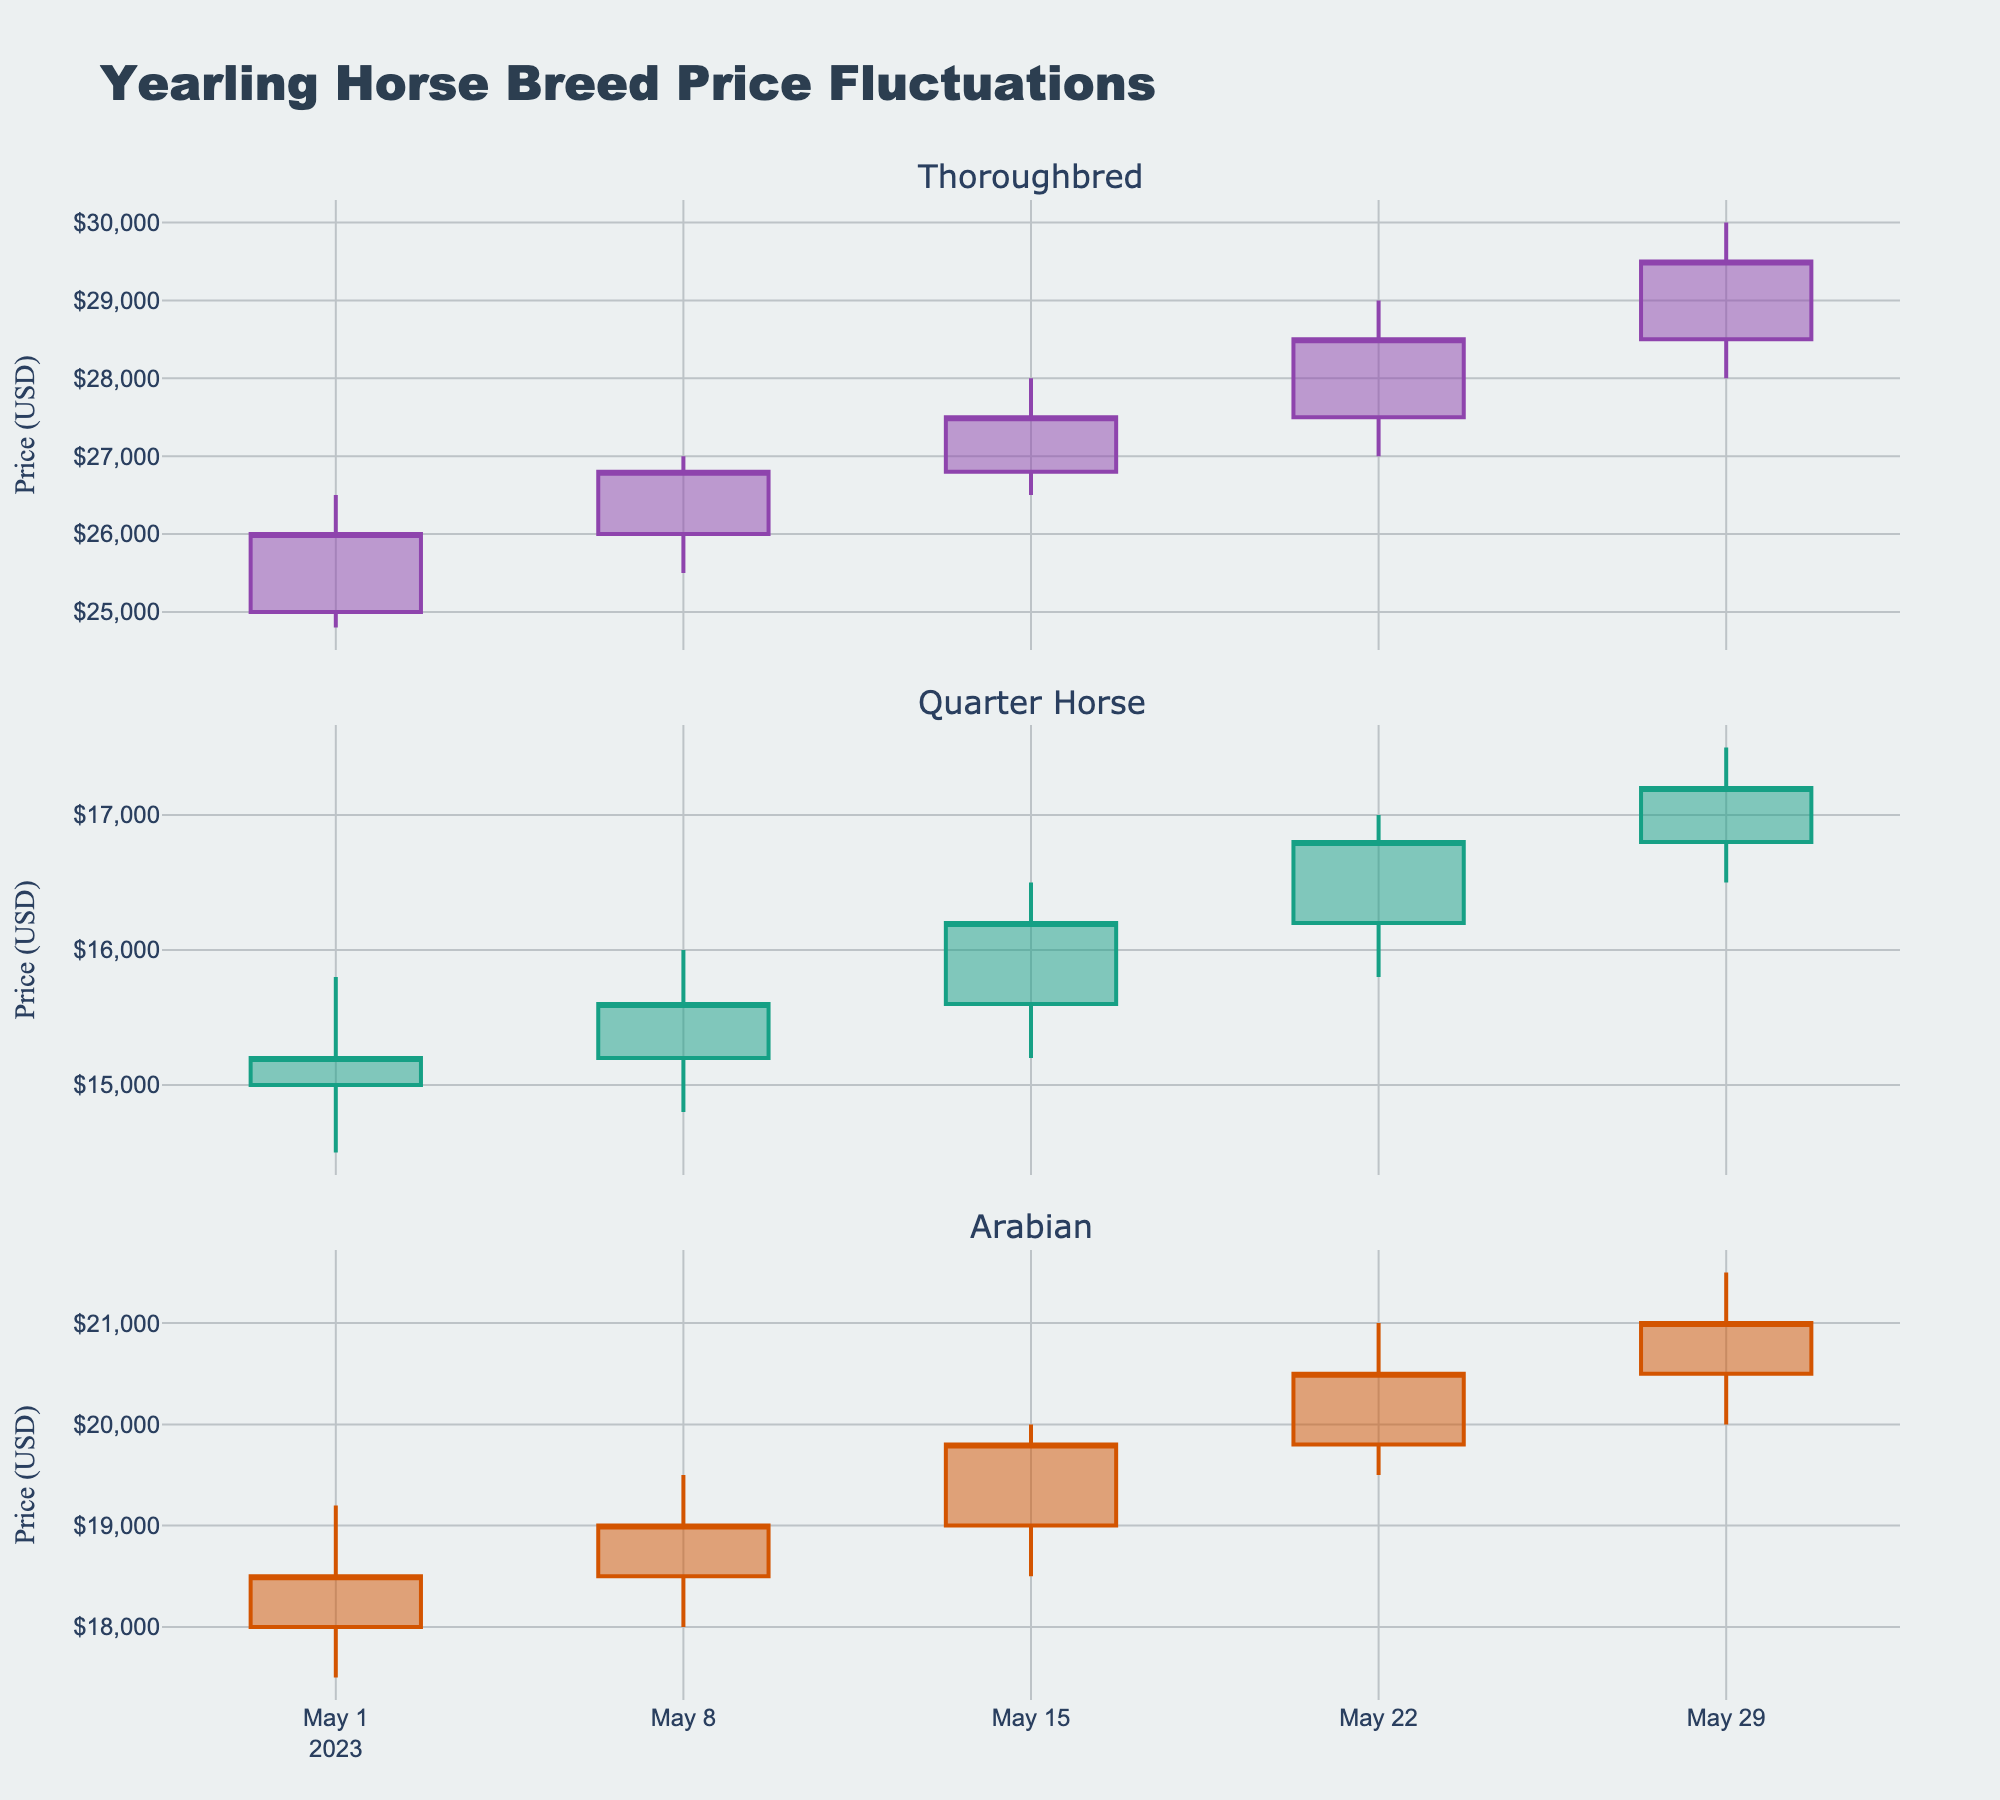Which month is the data from? The title of the chart indicates that it reflects monthly data, and the x-axis shows dates. Since the dates range from 2023-05-01 to 2023-05-29, the month is May 2023.
Answer: May 2023 How many different yearling horse breeds are shown in the chart? The title of the chart mentions "Yearling Horse Breed Price Fluctuations," and there are three subplots labeled Thoroughbred, Quarter Horse, and Arabian.
Answer: Three What is the closing price of the Thoroughbred on May 15th? Locate the date May 15th on the sub-plot for Thoroughbred. The opening (26,800), high (28,000), low (26,500), and closing (27,500) prices are visible, and the closing price is 27,500.
Answer: 27,500 On which date did the Quarter Horse have the highest high price? Look at the top prices within the Quarter Horse subplot. The highest recorded price (17,000) for Quarter Horse occurred on May 22nd.
Answer: May 22nd Between Thoroughbred and Arabian, which breed had a higher closing price on May 8th? Compare the closing prices on May 8th for both breeds: Thoroughbred (26,800) and Arabian (19,000). The Thoroughbred had a higher closing price.
Answer: Thoroughbred How does the price trend of the Arabian from May 1st to May 29th appear overall? Track the Arabian subplot from May 1st to May 29th. The closing prices range from 18,500 on May 1st to 21,000 on May 29th, showing an overall increasing trend.
Answer: Increasing Which breed has the largest price range (difference between high and low) on May 1st? Calculate the difference between high and low for each breed on May 1st: Thoroughbred (1,700), Quarter Horse (1,300), Arabian (1,700). Thoroughbred and Arabian both have the largest range of 1,700.
Answer: Thoroughbred and Arabian What is the average closing price of the Thoroughbred over the full month? To find the average, sum up the closing prices of Thoroughbred: (26,000 + 26,800 + 27,500 + 28,500 + 29,500) and divide by the number of points (5). (138,300 / 5) = 27,660.
Answer: 27,660 Which breed's closing prices show the least volatility over the month? Consider the consistency of closing prices by checking how much they vary. Examine each breed, and the Quarter Horse closing prices are less volatile compared to Thoroughbred and Arabian.
Answer: Quarter Horse 